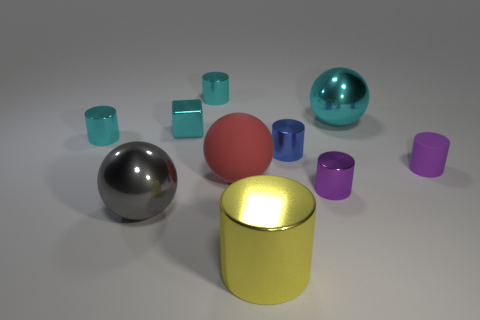There is a ball on the left side of the red rubber object; how big is it?
Make the answer very short. Large. What shape is the object that is behind the purple matte thing and on the right side of the purple metallic cylinder?
Provide a short and direct response. Sphere. There is a red rubber object that is the same shape as the large gray metal object; what is its size?
Your answer should be very brief. Large. What number of cyan spheres have the same material as the gray sphere?
Offer a terse response. 1. Is the color of the big matte object the same as the big shiny ball that is to the right of the yellow metallic cylinder?
Ensure brevity in your answer.  No. Are there more tiny cyan metallic cylinders than red rubber things?
Provide a short and direct response. Yes. What color is the small shiny cube?
Your answer should be very brief. Cyan. There is a shiny ball that is left of the yellow cylinder; does it have the same color as the big metallic cylinder?
Provide a short and direct response. No. What is the material of the large thing that is the same color as the tiny metallic cube?
Make the answer very short. Metal. What number of other tiny matte cylinders have the same color as the rubber cylinder?
Make the answer very short. 0. 